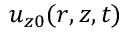Convert formula to latex. <formula><loc_0><loc_0><loc_500><loc_500>u _ { z 0 } ( r , z , t )</formula> 